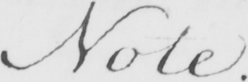What is written in this line of handwriting? Note . 